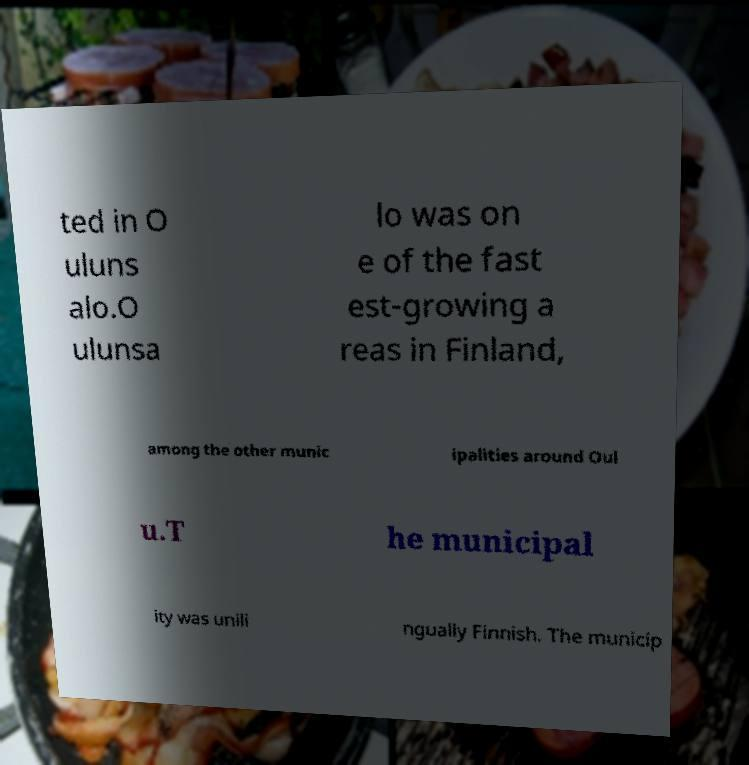Can you read and provide the text displayed in the image?This photo seems to have some interesting text. Can you extract and type it out for me? ted in O uluns alo.O ulunsa lo was on e of the fast est-growing a reas in Finland, among the other munic ipalities around Oul u.T he municipal ity was unili ngually Finnish. The municip 